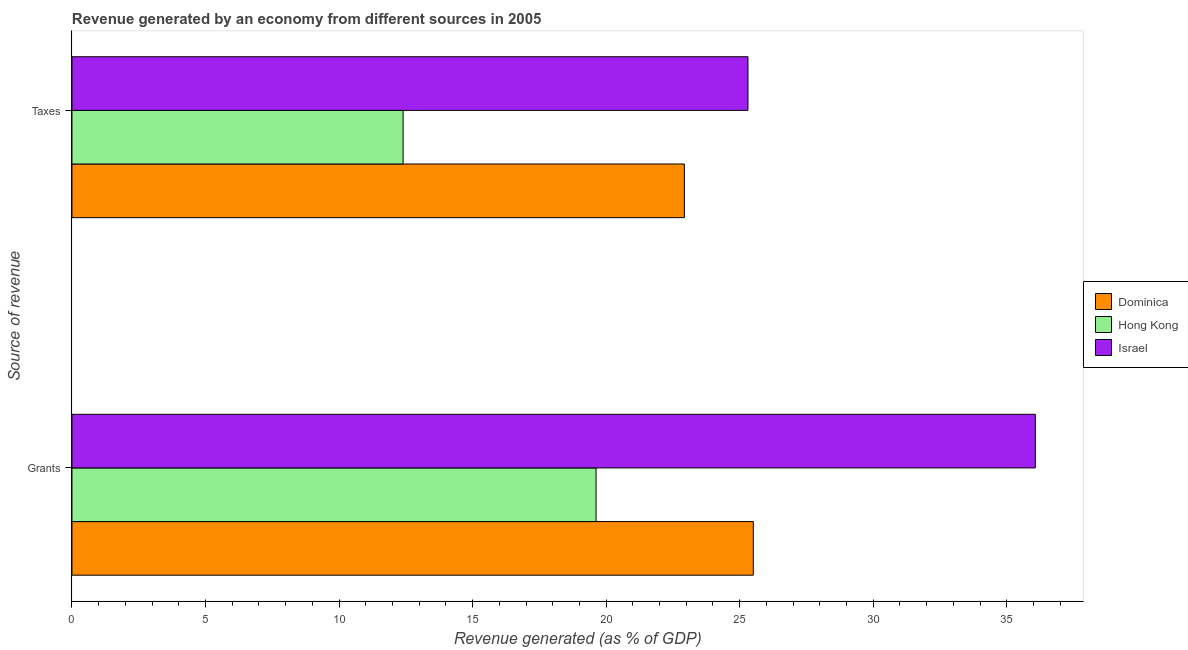What is the label of the 1st group of bars from the top?
Give a very brief answer. Taxes. What is the revenue generated by grants in Dominica?
Offer a very short reply. 25.51. Across all countries, what is the maximum revenue generated by grants?
Your response must be concise. 36.07. Across all countries, what is the minimum revenue generated by taxes?
Offer a terse response. 12.4. In which country was the revenue generated by grants maximum?
Provide a short and direct response. Israel. In which country was the revenue generated by taxes minimum?
Offer a very short reply. Hong Kong. What is the total revenue generated by grants in the graph?
Make the answer very short. 81.2. What is the difference between the revenue generated by taxes in Hong Kong and that in Israel?
Provide a succinct answer. -12.91. What is the difference between the revenue generated by grants in Israel and the revenue generated by taxes in Dominica?
Provide a short and direct response. 13.14. What is the average revenue generated by taxes per country?
Ensure brevity in your answer.  20.21. What is the difference between the revenue generated by grants and revenue generated by taxes in Hong Kong?
Provide a succinct answer. 7.23. What is the ratio of the revenue generated by taxes in Hong Kong to that in Israel?
Your answer should be compact. 0.49. Is the revenue generated by taxes in Israel less than that in Dominica?
Offer a terse response. No. In how many countries, is the revenue generated by grants greater than the average revenue generated by grants taken over all countries?
Provide a succinct answer. 1. What does the 2nd bar from the top in Grants represents?
Give a very brief answer. Hong Kong. What does the 1st bar from the bottom in Grants represents?
Give a very brief answer. Dominica. How many bars are there?
Offer a very short reply. 6. Are the values on the major ticks of X-axis written in scientific E-notation?
Ensure brevity in your answer.  No. Does the graph contain any zero values?
Your answer should be compact. No. Does the graph contain grids?
Offer a terse response. No. How are the legend labels stacked?
Your answer should be compact. Vertical. What is the title of the graph?
Your answer should be very brief. Revenue generated by an economy from different sources in 2005. Does "Croatia" appear as one of the legend labels in the graph?
Your response must be concise. No. What is the label or title of the X-axis?
Your answer should be very brief. Revenue generated (as % of GDP). What is the label or title of the Y-axis?
Offer a very short reply. Source of revenue. What is the Revenue generated (as % of GDP) in Dominica in Grants?
Provide a short and direct response. 25.51. What is the Revenue generated (as % of GDP) of Hong Kong in Grants?
Make the answer very short. 19.62. What is the Revenue generated (as % of GDP) of Israel in Grants?
Your answer should be compact. 36.07. What is the Revenue generated (as % of GDP) in Dominica in Taxes?
Give a very brief answer. 22.93. What is the Revenue generated (as % of GDP) of Hong Kong in Taxes?
Provide a short and direct response. 12.4. What is the Revenue generated (as % of GDP) in Israel in Taxes?
Ensure brevity in your answer.  25.31. Across all Source of revenue, what is the maximum Revenue generated (as % of GDP) of Dominica?
Keep it short and to the point. 25.51. Across all Source of revenue, what is the maximum Revenue generated (as % of GDP) of Hong Kong?
Your answer should be compact. 19.62. Across all Source of revenue, what is the maximum Revenue generated (as % of GDP) in Israel?
Your answer should be compact. 36.07. Across all Source of revenue, what is the minimum Revenue generated (as % of GDP) in Dominica?
Keep it short and to the point. 22.93. Across all Source of revenue, what is the minimum Revenue generated (as % of GDP) of Hong Kong?
Your answer should be compact. 12.4. Across all Source of revenue, what is the minimum Revenue generated (as % of GDP) of Israel?
Make the answer very short. 25.31. What is the total Revenue generated (as % of GDP) of Dominica in the graph?
Offer a terse response. 48.44. What is the total Revenue generated (as % of GDP) of Hong Kong in the graph?
Keep it short and to the point. 32.02. What is the total Revenue generated (as % of GDP) in Israel in the graph?
Give a very brief answer. 61.38. What is the difference between the Revenue generated (as % of GDP) in Dominica in Grants and that in Taxes?
Keep it short and to the point. 2.58. What is the difference between the Revenue generated (as % of GDP) of Hong Kong in Grants and that in Taxes?
Give a very brief answer. 7.23. What is the difference between the Revenue generated (as % of GDP) in Israel in Grants and that in Taxes?
Give a very brief answer. 10.76. What is the difference between the Revenue generated (as % of GDP) in Dominica in Grants and the Revenue generated (as % of GDP) in Hong Kong in Taxes?
Keep it short and to the point. 13.11. What is the difference between the Revenue generated (as % of GDP) of Dominica in Grants and the Revenue generated (as % of GDP) of Israel in Taxes?
Keep it short and to the point. 0.2. What is the difference between the Revenue generated (as % of GDP) of Hong Kong in Grants and the Revenue generated (as % of GDP) of Israel in Taxes?
Provide a succinct answer. -5.69. What is the average Revenue generated (as % of GDP) of Dominica per Source of revenue?
Provide a succinct answer. 24.22. What is the average Revenue generated (as % of GDP) in Hong Kong per Source of revenue?
Offer a terse response. 16.01. What is the average Revenue generated (as % of GDP) of Israel per Source of revenue?
Give a very brief answer. 30.69. What is the difference between the Revenue generated (as % of GDP) of Dominica and Revenue generated (as % of GDP) of Hong Kong in Grants?
Your answer should be compact. 5.89. What is the difference between the Revenue generated (as % of GDP) in Dominica and Revenue generated (as % of GDP) in Israel in Grants?
Make the answer very short. -10.56. What is the difference between the Revenue generated (as % of GDP) in Hong Kong and Revenue generated (as % of GDP) in Israel in Grants?
Make the answer very short. -16.45. What is the difference between the Revenue generated (as % of GDP) of Dominica and Revenue generated (as % of GDP) of Hong Kong in Taxes?
Your answer should be very brief. 10.53. What is the difference between the Revenue generated (as % of GDP) in Dominica and Revenue generated (as % of GDP) in Israel in Taxes?
Your answer should be compact. -2.38. What is the difference between the Revenue generated (as % of GDP) of Hong Kong and Revenue generated (as % of GDP) of Israel in Taxes?
Make the answer very short. -12.91. What is the ratio of the Revenue generated (as % of GDP) of Dominica in Grants to that in Taxes?
Ensure brevity in your answer.  1.11. What is the ratio of the Revenue generated (as % of GDP) of Hong Kong in Grants to that in Taxes?
Offer a very short reply. 1.58. What is the ratio of the Revenue generated (as % of GDP) of Israel in Grants to that in Taxes?
Make the answer very short. 1.43. What is the difference between the highest and the second highest Revenue generated (as % of GDP) in Dominica?
Your answer should be very brief. 2.58. What is the difference between the highest and the second highest Revenue generated (as % of GDP) in Hong Kong?
Offer a very short reply. 7.23. What is the difference between the highest and the second highest Revenue generated (as % of GDP) of Israel?
Your answer should be compact. 10.76. What is the difference between the highest and the lowest Revenue generated (as % of GDP) in Dominica?
Make the answer very short. 2.58. What is the difference between the highest and the lowest Revenue generated (as % of GDP) in Hong Kong?
Your answer should be very brief. 7.23. What is the difference between the highest and the lowest Revenue generated (as % of GDP) in Israel?
Give a very brief answer. 10.76. 